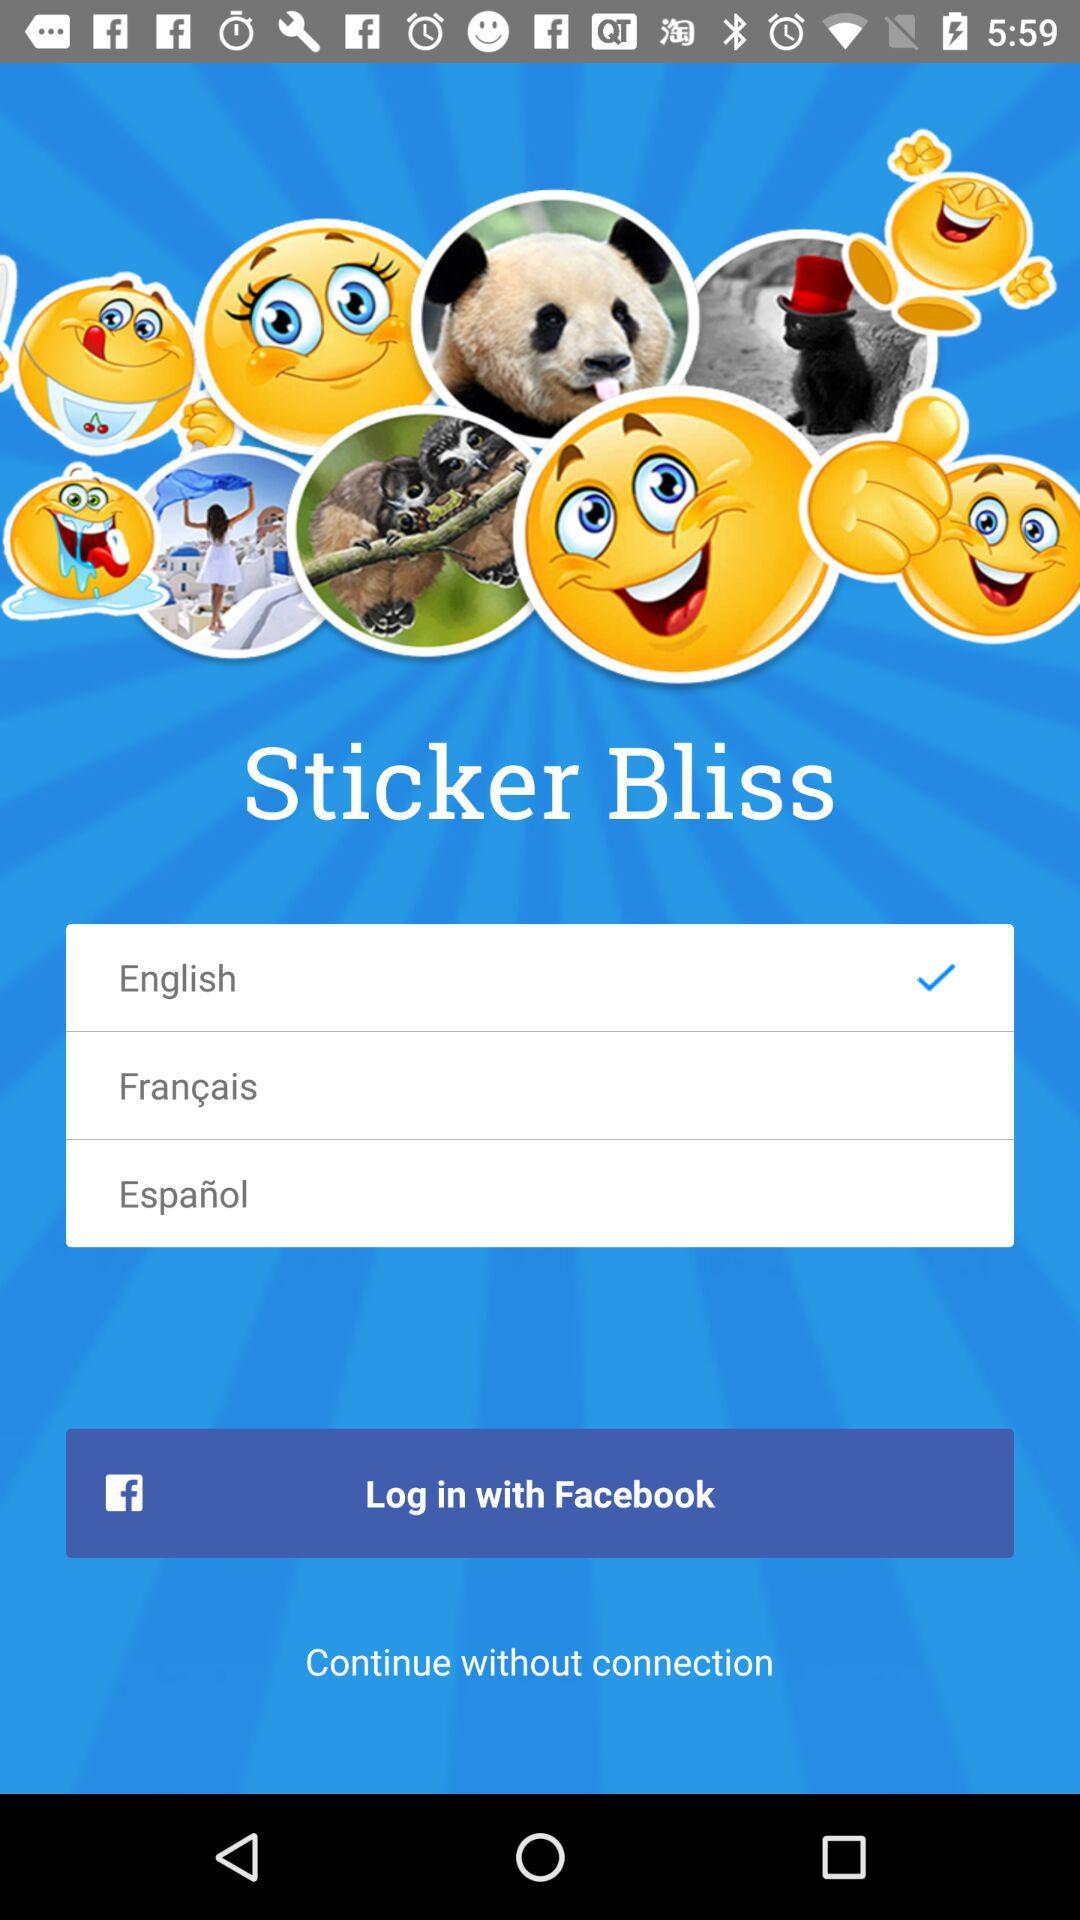What is the application name? The application name is "Sticker Bliss". 